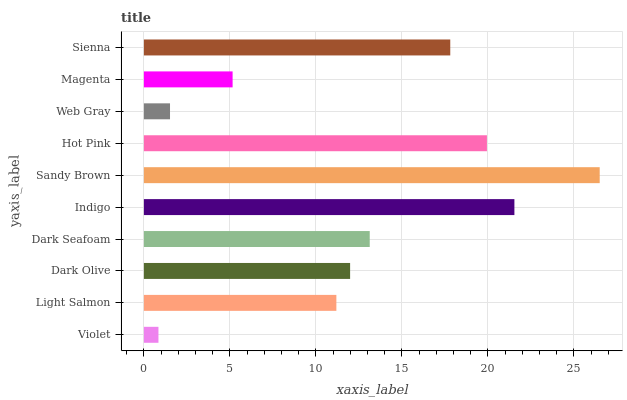Is Violet the minimum?
Answer yes or no. Yes. Is Sandy Brown the maximum?
Answer yes or no. Yes. Is Light Salmon the minimum?
Answer yes or no. No. Is Light Salmon the maximum?
Answer yes or no. No. Is Light Salmon greater than Violet?
Answer yes or no. Yes. Is Violet less than Light Salmon?
Answer yes or no. Yes. Is Violet greater than Light Salmon?
Answer yes or no. No. Is Light Salmon less than Violet?
Answer yes or no. No. Is Dark Seafoam the high median?
Answer yes or no. Yes. Is Dark Olive the low median?
Answer yes or no. Yes. Is Sandy Brown the high median?
Answer yes or no. No. Is Magenta the low median?
Answer yes or no. No. 